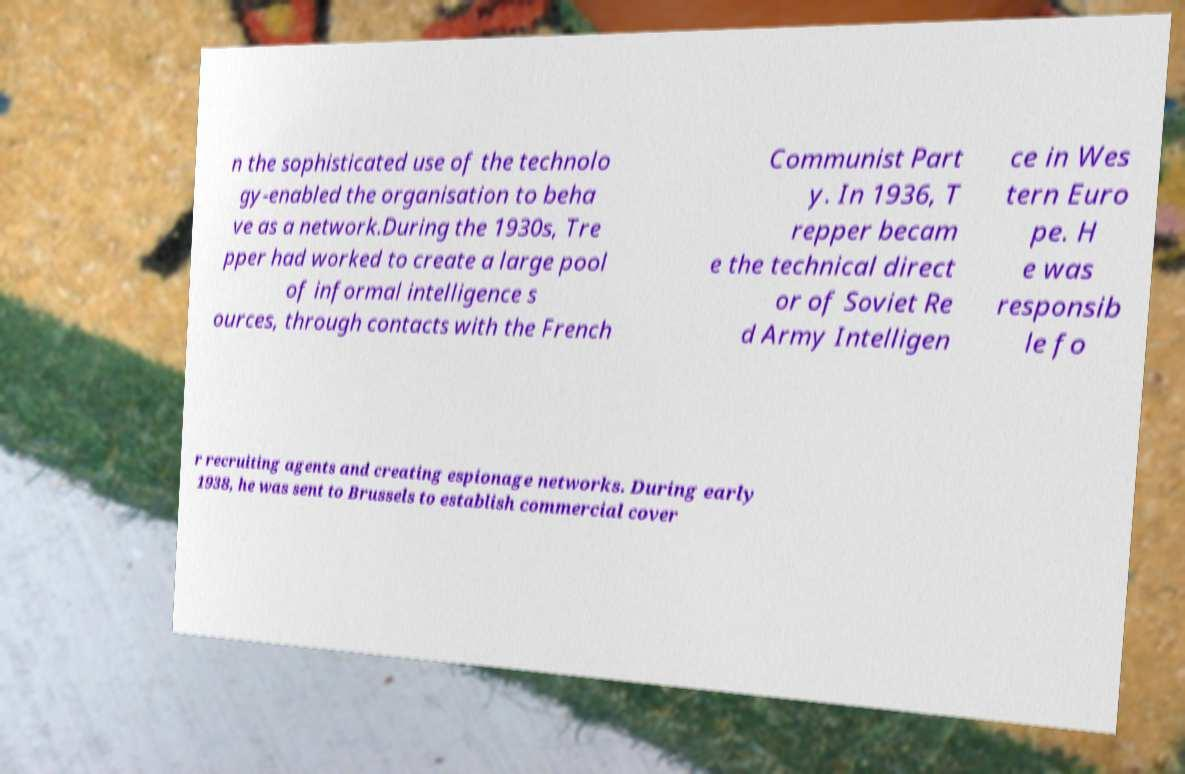Could you assist in decoding the text presented in this image and type it out clearly? n the sophisticated use of the technolo gy-enabled the organisation to beha ve as a network.During the 1930s, Tre pper had worked to create a large pool of informal intelligence s ources, through contacts with the French Communist Part y. In 1936, T repper becam e the technical direct or of Soviet Re d Army Intelligen ce in Wes tern Euro pe. H e was responsib le fo r recruiting agents and creating espionage networks. During early 1938, he was sent to Brussels to establish commercial cover 